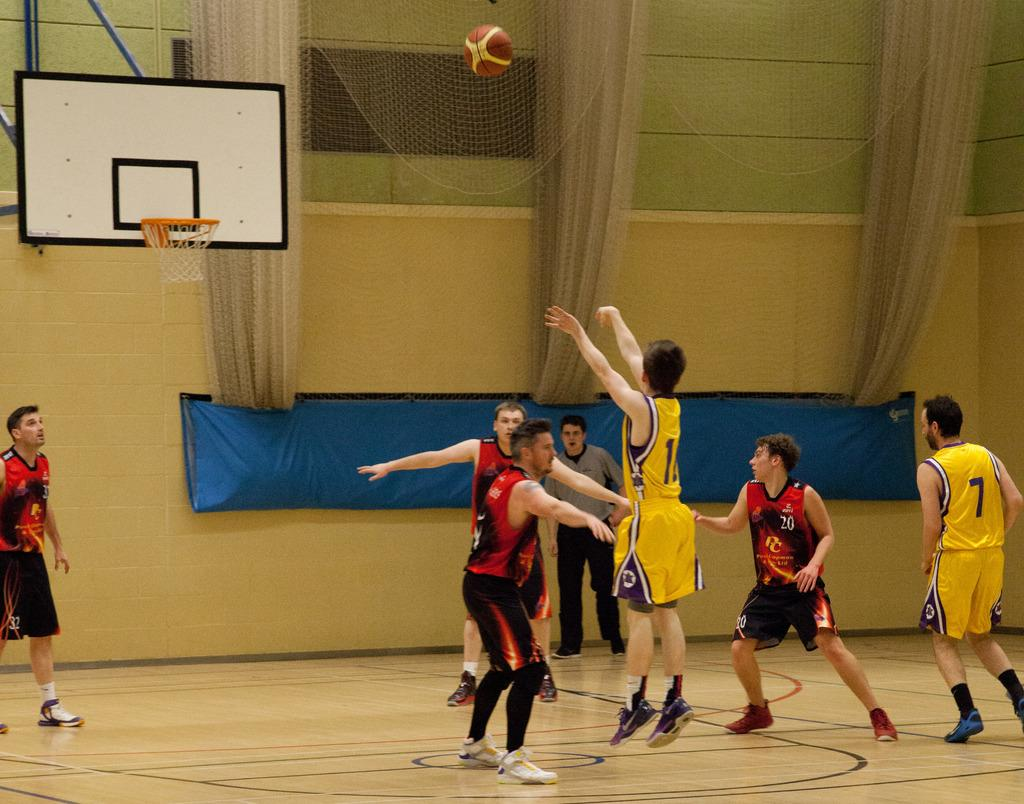<image>
Render a clear and concise summary of the photo. a group of young men playing basketball with number 11 from the yellow team attempting a shot 